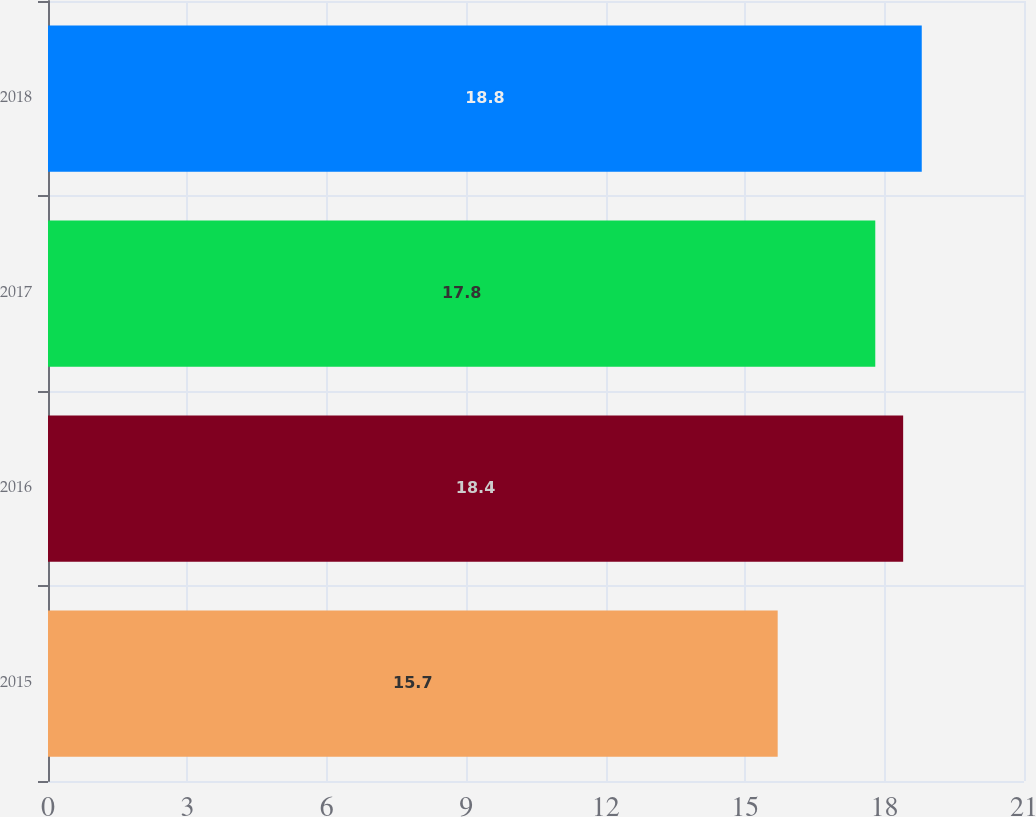<chart> <loc_0><loc_0><loc_500><loc_500><bar_chart><fcel>2015<fcel>2016<fcel>2017<fcel>2018<nl><fcel>15.7<fcel>18.4<fcel>17.8<fcel>18.8<nl></chart> 